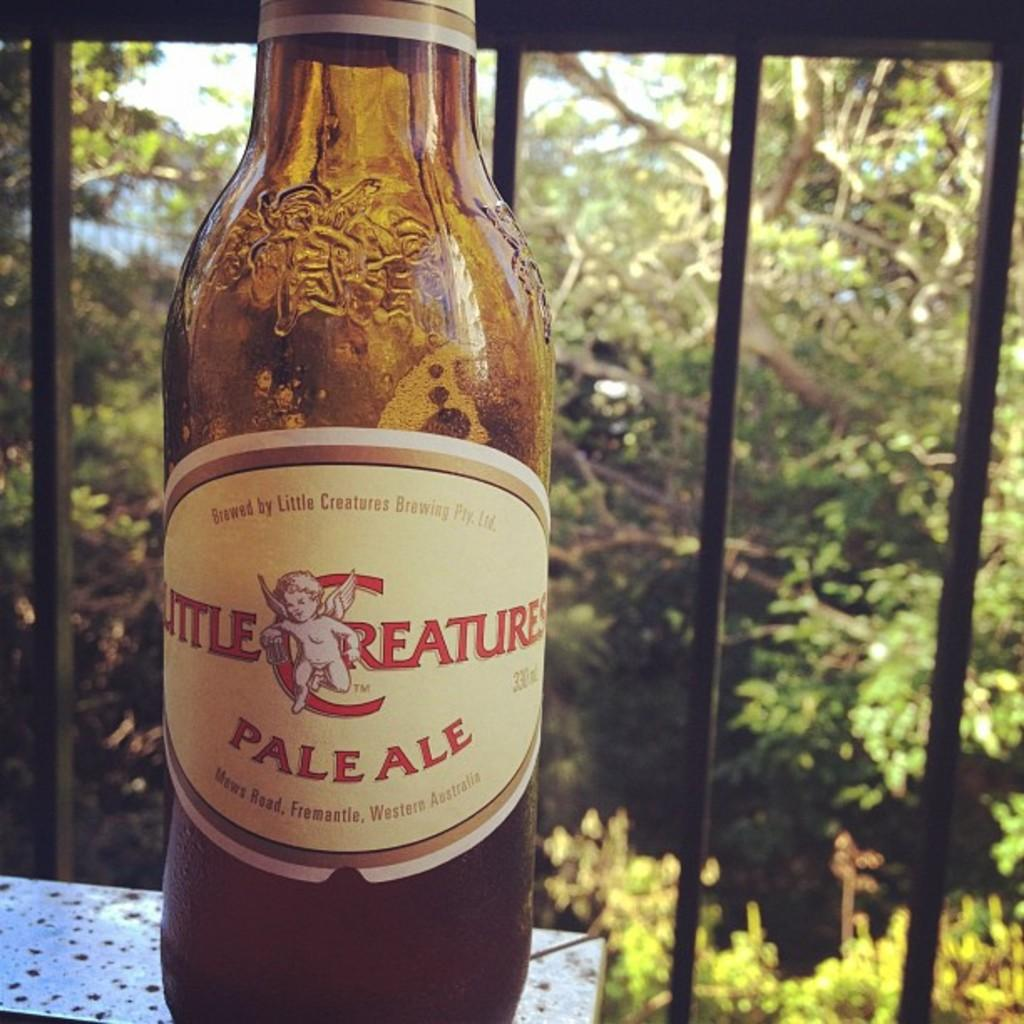What is the main object in the image? There is a wine bottle in the image. Where is the wine bottle located? The wine bottle is on a surface. What can be seen in the background of the image? There is a railing, trees, and the sky visible in the background of the image. What scientific discovery can be seen in the image? There is no scientific discovery present in the image. --- Facts: 1. There is a person in the image. 2. The person is wearing a hat. 3. The person is holding a book. 4. There is a table in the image. 5. The table has a lamp on it. Absurd Topics: unicorn, magic wand, fairy Conversation: Who or what is the main subject in the image? The main subject in the image is a person. What is the person wearing? The person is wearing a hat. What is the person holding? The person is holding a book. What can be seen on the table? There is a lamp on the table. Reasoning: Let's think step by step in order to continue the user text directly without *any* additional interjections. We start by identifying the main subject of the image, which is a person. Next, we describe the person's attire, specifically mentioning that they are wearing a hat. Then, we observe the actions of the person, noting that they are holding a book. Finally, we describe the objects on the table, which includes a lamp. Absurd Question/Answer: Can you see a unicorn in the image? No, there is no unicorn present in the image. --- Facts: 1. There is a group of people in the image. 2. The people are sitting on chairs. 3. There is a large cake on a table. 4. The cake has multiple layers. 5. The cake has colorful decorations on it. Absurd Topics: flying saucer, alien creature, outer space Conversation: How many people are present in the image? There is a group of people in the image. What are the people doing in the image? The people are sitting on chairs. What can be seen on the table in the image? There is a large cake on a table. Can you describe the cake in the image? The cake has multiple layers and colorful decorations on it. Reasoning: Let's think step by step in order to continue the user text directly without *any* additional interjections. We start by identifying the main subject of the image, which is a group of people. Next, we describe the people's actions, noting that they are sitting on chairs. Then, we expand the conversation to include details about the cake on the table, which includes multiple layers and colorful decorations. Absurd Question/Answer: 